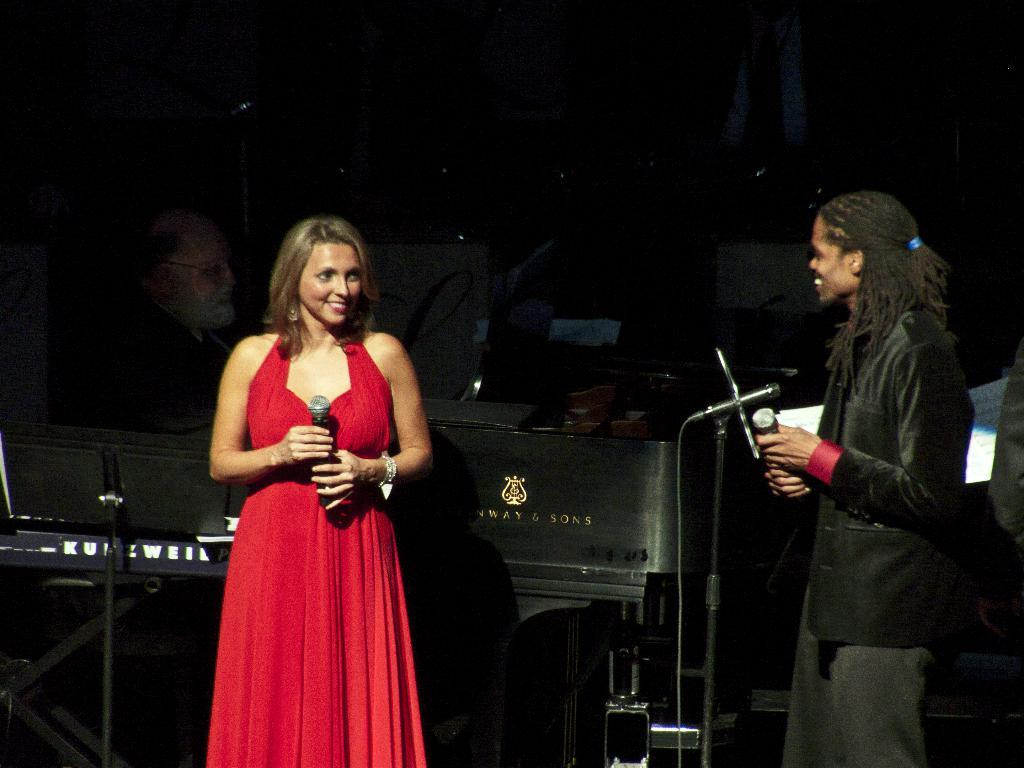How many people are in the image? There are two people in the image. Can you describe the appearance of the girl in the image? The girl is wearing a red dress. What is the girl holding in the image? The girl is holding a microphone. How can you describe the other person in the image? The other person is wearing a black dress. What book is the secretary reading in the image? There is no secretary or book present in the image. 